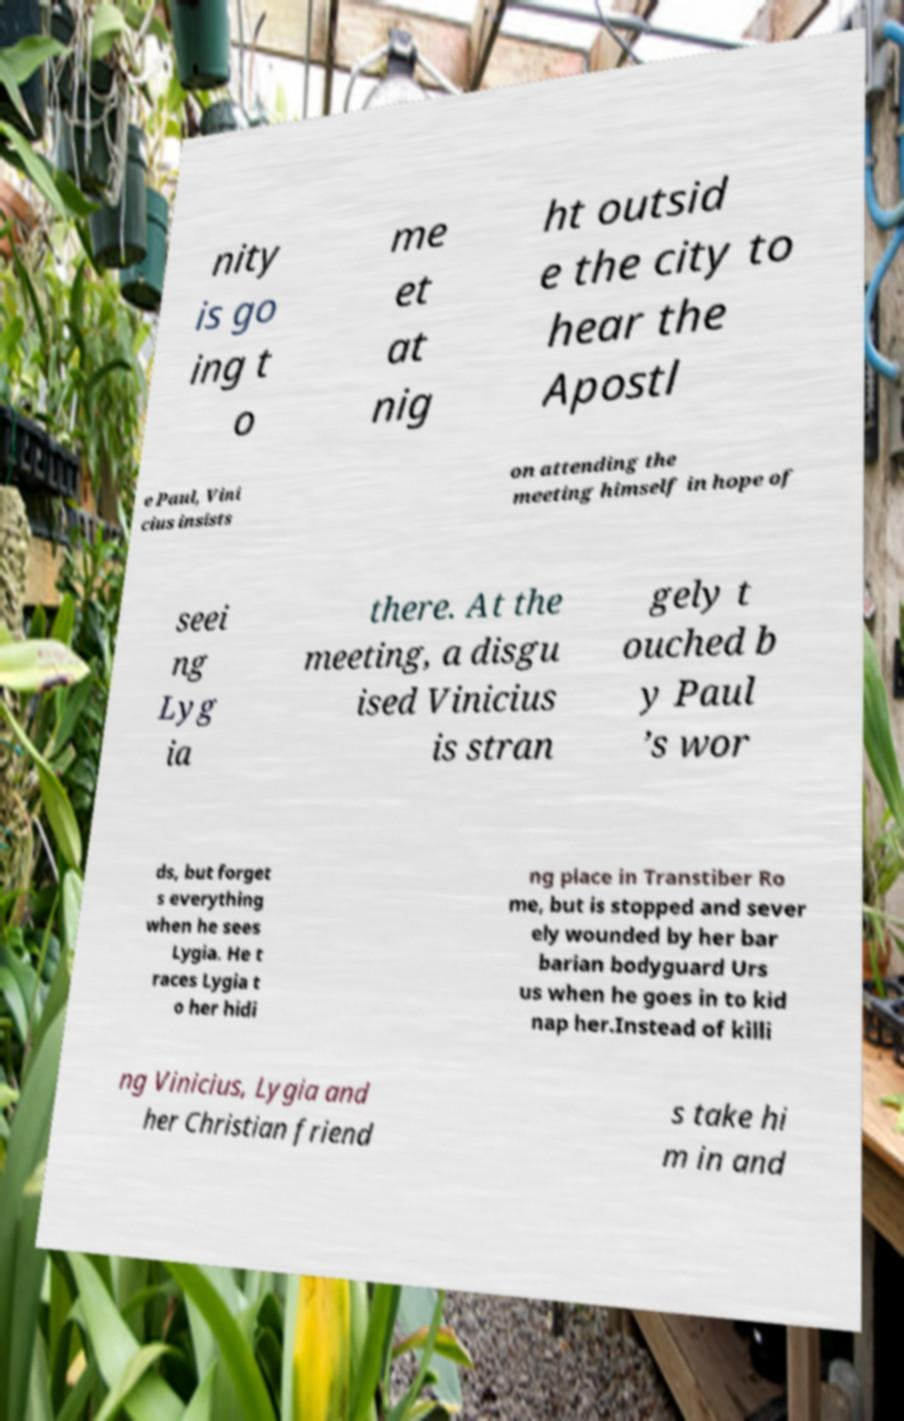I need the written content from this picture converted into text. Can you do that? nity is go ing t o me et at nig ht outsid e the city to hear the Apostl e Paul, Vini cius insists on attending the meeting himself in hope of seei ng Lyg ia there. At the meeting, a disgu ised Vinicius is stran gely t ouched b y Paul ’s wor ds, but forget s everything when he sees Lygia. He t races Lygia t o her hidi ng place in Transtiber Ro me, but is stopped and sever ely wounded by her bar barian bodyguard Urs us when he goes in to kid nap her.Instead of killi ng Vinicius, Lygia and her Christian friend s take hi m in and 